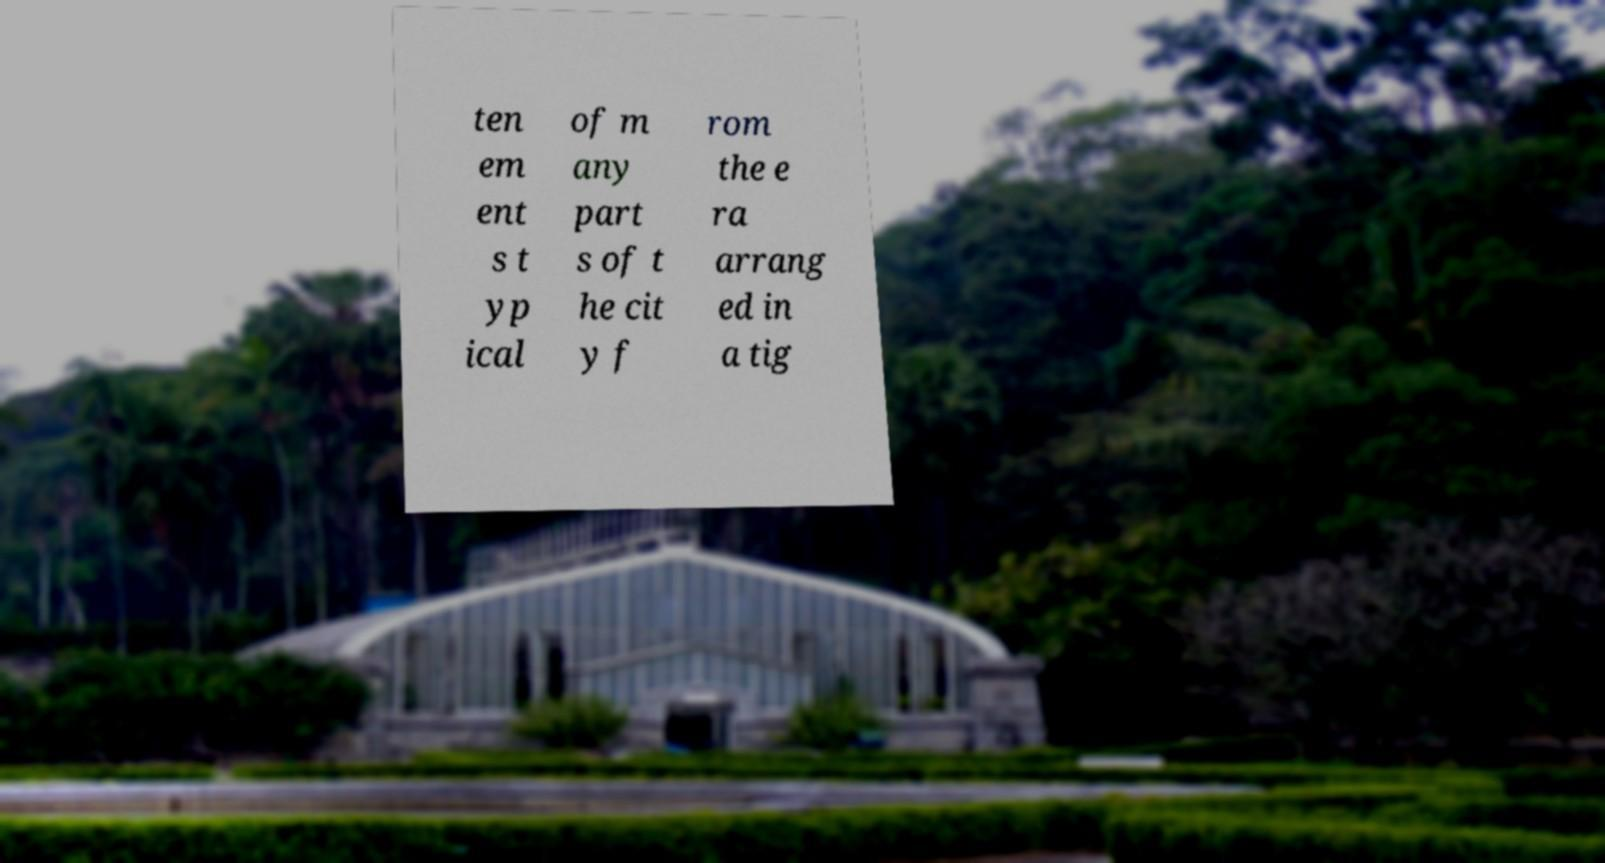Can you read and provide the text displayed in the image?This photo seems to have some interesting text. Can you extract and type it out for me? ten em ent s t yp ical of m any part s of t he cit y f rom the e ra arrang ed in a tig 